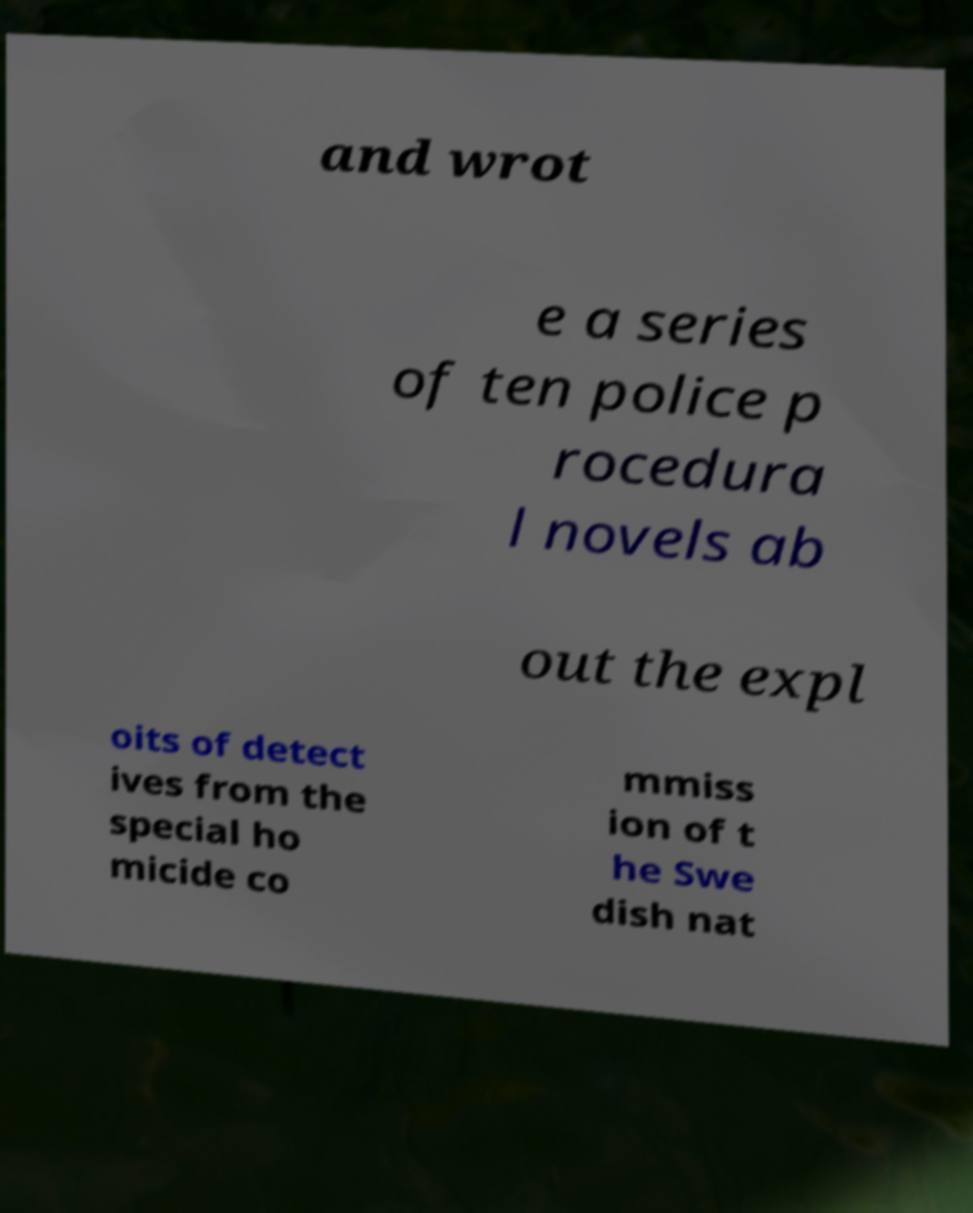Could you assist in decoding the text presented in this image and type it out clearly? and wrot e a series of ten police p rocedura l novels ab out the expl oits of detect ives from the special ho micide co mmiss ion of t he Swe dish nat 